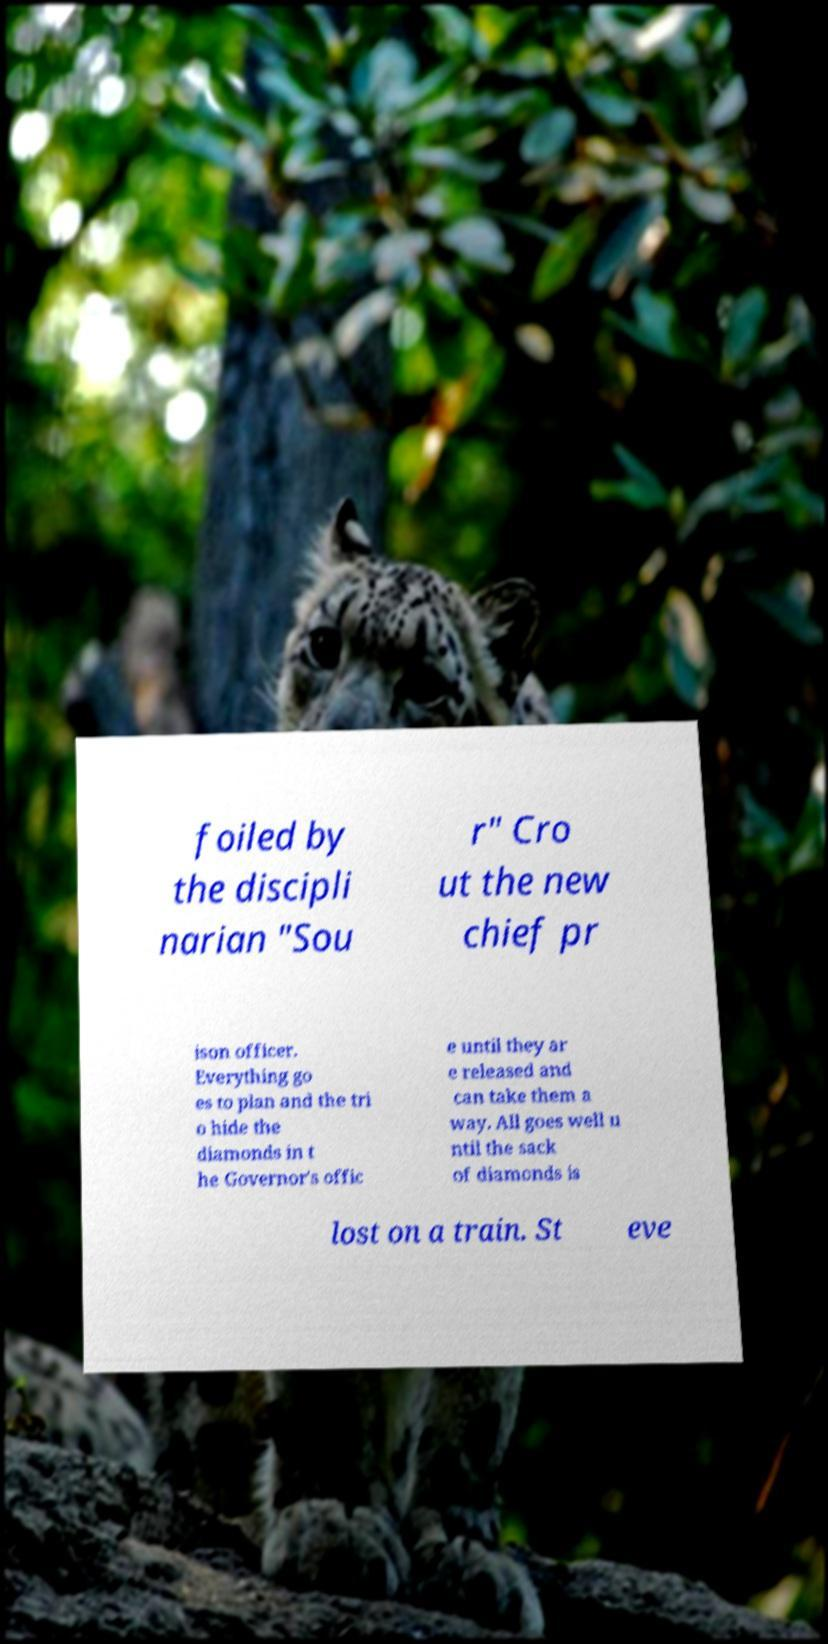For documentation purposes, I need the text within this image transcribed. Could you provide that? foiled by the discipli narian "Sou r" Cro ut the new chief pr ison officer. Everything go es to plan and the tri o hide the diamonds in t he Governor's offic e until they ar e released and can take them a way. All goes well u ntil the sack of diamonds is lost on a train. St eve 